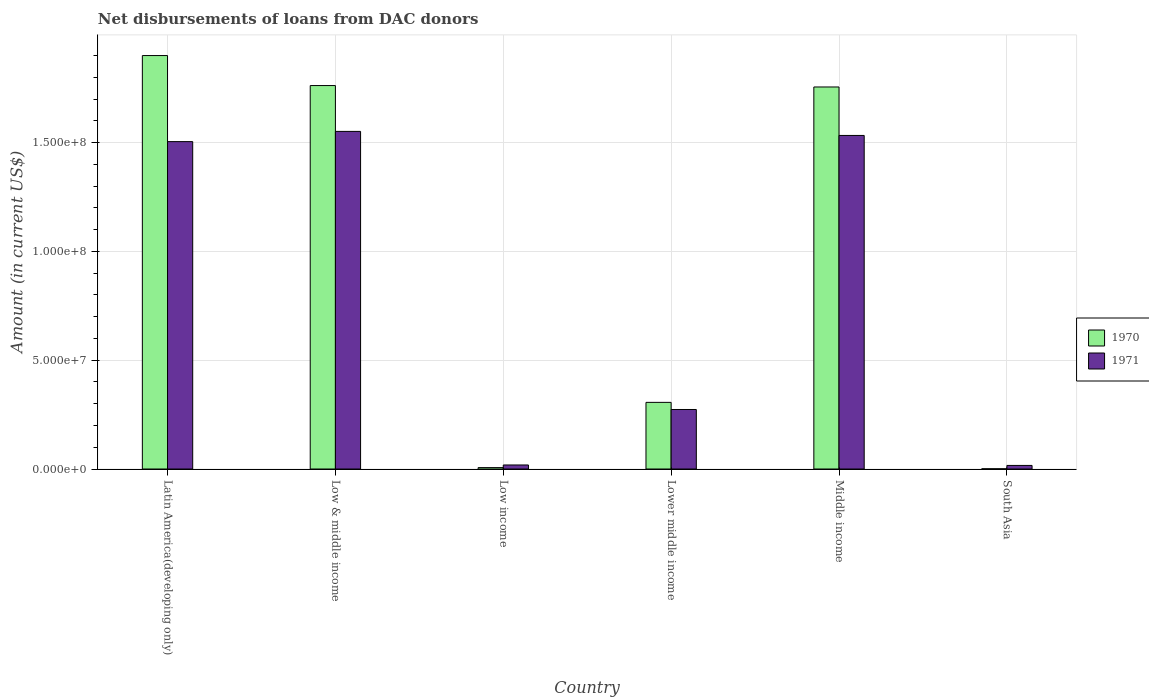How many different coloured bars are there?
Keep it short and to the point. 2. How many groups of bars are there?
Keep it short and to the point. 6. In how many cases, is the number of bars for a given country not equal to the number of legend labels?
Give a very brief answer. 0. What is the amount of loans disbursed in 1971 in Low income?
Your response must be concise. 1.86e+06. Across all countries, what is the maximum amount of loans disbursed in 1971?
Give a very brief answer. 1.55e+08. Across all countries, what is the minimum amount of loans disbursed in 1971?
Ensure brevity in your answer.  1.65e+06. In which country was the amount of loans disbursed in 1970 maximum?
Your response must be concise. Latin America(developing only). What is the total amount of loans disbursed in 1971 in the graph?
Provide a short and direct response. 4.90e+08. What is the difference between the amount of loans disbursed in 1971 in Middle income and that in South Asia?
Ensure brevity in your answer.  1.52e+08. What is the difference between the amount of loans disbursed in 1971 in Lower middle income and the amount of loans disbursed in 1970 in Low & middle income?
Make the answer very short. -1.49e+08. What is the average amount of loans disbursed in 1971 per country?
Keep it short and to the point. 8.16e+07. What is the difference between the amount of loans disbursed of/in 1971 and amount of loans disbursed of/in 1970 in Low income?
Your answer should be compact. 1.21e+06. What is the ratio of the amount of loans disbursed in 1971 in Latin America(developing only) to that in Lower middle income?
Provide a short and direct response. 5.5. Is the amount of loans disbursed in 1971 in Low & middle income less than that in Low income?
Give a very brief answer. No. What is the difference between the highest and the second highest amount of loans disbursed in 1971?
Ensure brevity in your answer.  4.69e+06. What is the difference between the highest and the lowest amount of loans disbursed in 1970?
Your response must be concise. 1.90e+08. Is the sum of the amount of loans disbursed in 1970 in Lower middle income and Middle income greater than the maximum amount of loans disbursed in 1971 across all countries?
Provide a short and direct response. Yes. How many bars are there?
Offer a very short reply. 12. Are the values on the major ticks of Y-axis written in scientific E-notation?
Your response must be concise. Yes. Where does the legend appear in the graph?
Give a very brief answer. Center right. How are the legend labels stacked?
Offer a very short reply. Vertical. What is the title of the graph?
Your answer should be very brief. Net disbursements of loans from DAC donors. Does "1991" appear as one of the legend labels in the graph?
Your answer should be compact. No. What is the label or title of the X-axis?
Keep it short and to the point. Country. What is the label or title of the Y-axis?
Make the answer very short. Amount (in current US$). What is the Amount (in current US$) of 1970 in Latin America(developing only)?
Offer a terse response. 1.90e+08. What is the Amount (in current US$) in 1971 in Latin America(developing only)?
Keep it short and to the point. 1.50e+08. What is the Amount (in current US$) of 1970 in Low & middle income?
Your response must be concise. 1.76e+08. What is the Amount (in current US$) of 1971 in Low & middle income?
Provide a short and direct response. 1.55e+08. What is the Amount (in current US$) in 1970 in Low income?
Provide a succinct answer. 6.47e+05. What is the Amount (in current US$) in 1971 in Low income?
Offer a terse response. 1.86e+06. What is the Amount (in current US$) of 1970 in Lower middle income?
Provide a succinct answer. 3.06e+07. What is the Amount (in current US$) of 1971 in Lower middle income?
Your answer should be compact. 2.74e+07. What is the Amount (in current US$) in 1970 in Middle income?
Your response must be concise. 1.76e+08. What is the Amount (in current US$) in 1971 in Middle income?
Give a very brief answer. 1.53e+08. What is the Amount (in current US$) of 1970 in South Asia?
Your response must be concise. 1.09e+05. What is the Amount (in current US$) in 1971 in South Asia?
Keep it short and to the point. 1.65e+06. Across all countries, what is the maximum Amount (in current US$) in 1970?
Your response must be concise. 1.90e+08. Across all countries, what is the maximum Amount (in current US$) of 1971?
Provide a short and direct response. 1.55e+08. Across all countries, what is the minimum Amount (in current US$) of 1970?
Provide a short and direct response. 1.09e+05. Across all countries, what is the minimum Amount (in current US$) in 1971?
Provide a short and direct response. 1.65e+06. What is the total Amount (in current US$) in 1970 in the graph?
Your response must be concise. 5.73e+08. What is the total Amount (in current US$) in 1971 in the graph?
Make the answer very short. 4.90e+08. What is the difference between the Amount (in current US$) of 1970 in Latin America(developing only) and that in Low & middle income?
Offer a terse response. 1.38e+07. What is the difference between the Amount (in current US$) of 1971 in Latin America(developing only) and that in Low & middle income?
Make the answer very short. -4.69e+06. What is the difference between the Amount (in current US$) of 1970 in Latin America(developing only) and that in Low income?
Give a very brief answer. 1.89e+08. What is the difference between the Amount (in current US$) in 1971 in Latin America(developing only) and that in Low income?
Keep it short and to the point. 1.49e+08. What is the difference between the Amount (in current US$) of 1970 in Latin America(developing only) and that in Lower middle income?
Provide a short and direct response. 1.59e+08. What is the difference between the Amount (in current US$) of 1971 in Latin America(developing only) and that in Lower middle income?
Your answer should be very brief. 1.23e+08. What is the difference between the Amount (in current US$) in 1970 in Latin America(developing only) and that in Middle income?
Offer a very short reply. 1.44e+07. What is the difference between the Amount (in current US$) of 1971 in Latin America(developing only) and that in Middle income?
Offer a very short reply. -2.84e+06. What is the difference between the Amount (in current US$) of 1970 in Latin America(developing only) and that in South Asia?
Provide a short and direct response. 1.90e+08. What is the difference between the Amount (in current US$) in 1971 in Latin America(developing only) and that in South Asia?
Your answer should be compact. 1.49e+08. What is the difference between the Amount (in current US$) in 1970 in Low & middle income and that in Low income?
Provide a succinct answer. 1.76e+08. What is the difference between the Amount (in current US$) of 1971 in Low & middle income and that in Low income?
Make the answer very short. 1.53e+08. What is the difference between the Amount (in current US$) in 1970 in Low & middle income and that in Lower middle income?
Keep it short and to the point. 1.46e+08. What is the difference between the Amount (in current US$) of 1971 in Low & middle income and that in Lower middle income?
Your answer should be compact. 1.28e+08. What is the difference between the Amount (in current US$) of 1970 in Low & middle income and that in Middle income?
Give a very brief answer. 6.47e+05. What is the difference between the Amount (in current US$) in 1971 in Low & middle income and that in Middle income?
Offer a very short reply. 1.86e+06. What is the difference between the Amount (in current US$) of 1970 in Low & middle income and that in South Asia?
Make the answer very short. 1.76e+08. What is the difference between the Amount (in current US$) in 1971 in Low & middle income and that in South Asia?
Your answer should be compact. 1.53e+08. What is the difference between the Amount (in current US$) of 1970 in Low income and that in Lower middle income?
Ensure brevity in your answer.  -3.00e+07. What is the difference between the Amount (in current US$) of 1971 in Low income and that in Lower middle income?
Provide a short and direct response. -2.55e+07. What is the difference between the Amount (in current US$) of 1970 in Low income and that in Middle income?
Your response must be concise. -1.75e+08. What is the difference between the Amount (in current US$) of 1971 in Low income and that in Middle income?
Ensure brevity in your answer.  -1.51e+08. What is the difference between the Amount (in current US$) in 1970 in Low income and that in South Asia?
Keep it short and to the point. 5.38e+05. What is the difference between the Amount (in current US$) in 1971 in Low income and that in South Asia?
Your response must be concise. 2.09e+05. What is the difference between the Amount (in current US$) of 1970 in Lower middle income and that in Middle income?
Ensure brevity in your answer.  -1.45e+08. What is the difference between the Amount (in current US$) in 1971 in Lower middle income and that in Middle income?
Your answer should be compact. -1.26e+08. What is the difference between the Amount (in current US$) of 1970 in Lower middle income and that in South Asia?
Keep it short and to the point. 3.05e+07. What is the difference between the Amount (in current US$) of 1971 in Lower middle income and that in South Asia?
Your answer should be very brief. 2.57e+07. What is the difference between the Amount (in current US$) of 1970 in Middle income and that in South Asia?
Keep it short and to the point. 1.75e+08. What is the difference between the Amount (in current US$) in 1971 in Middle income and that in South Asia?
Your answer should be compact. 1.52e+08. What is the difference between the Amount (in current US$) in 1970 in Latin America(developing only) and the Amount (in current US$) in 1971 in Low & middle income?
Your answer should be compact. 3.49e+07. What is the difference between the Amount (in current US$) in 1970 in Latin America(developing only) and the Amount (in current US$) in 1971 in Low income?
Your answer should be compact. 1.88e+08. What is the difference between the Amount (in current US$) of 1970 in Latin America(developing only) and the Amount (in current US$) of 1971 in Lower middle income?
Make the answer very short. 1.63e+08. What is the difference between the Amount (in current US$) of 1970 in Latin America(developing only) and the Amount (in current US$) of 1971 in Middle income?
Ensure brevity in your answer.  3.67e+07. What is the difference between the Amount (in current US$) of 1970 in Latin America(developing only) and the Amount (in current US$) of 1971 in South Asia?
Give a very brief answer. 1.88e+08. What is the difference between the Amount (in current US$) of 1970 in Low & middle income and the Amount (in current US$) of 1971 in Low income?
Keep it short and to the point. 1.74e+08. What is the difference between the Amount (in current US$) in 1970 in Low & middle income and the Amount (in current US$) in 1971 in Lower middle income?
Your answer should be compact. 1.49e+08. What is the difference between the Amount (in current US$) in 1970 in Low & middle income and the Amount (in current US$) in 1971 in Middle income?
Make the answer very short. 2.29e+07. What is the difference between the Amount (in current US$) in 1970 in Low & middle income and the Amount (in current US$) in 1971 in South Asia?
Ensure brevity in your answer.  1.75e+08. What is the difference between the Amount (in current US$) of 1970 in Low income and the Amount (in current US$) of 1971 in Lower middle income?
Ensure brevity in your answer.  -2.67e+07. What is the difference between the Amount (in current US$) of 1970 in Low income and the Amount (in current US$) of 1971 in Middle income?
Provide a short and direct response. -1.53e+08. What is the difference between the Amount (in current US$) of 1970 in Low income and the Amount (in current US$) of 1971 in South Asia?
Provide a succinct answer. -1.00e+06. What is the difference between the Amount (in current US$) of 1970 in Lower middle income and the Amount (in current US$) of 1971 in Middle income?
Your response must be concise. -1.23e+08. What is the difference between the Amount (in current US$) of 1970 in Lower middle income and the Amount (in current US$) of 1971 in South Asia?
Your response must be concise. 2.90e+07. What is the difference between the Amount (in current US$) of 1970 in Middle income and the Amount (in current US$) of 1971 in South Asia?
Provide a short and direct response. 1.74e+08. What is the average Amount (in current US$) in 1970 per country?
Offer a terse response. 9.55e+07. What is the average Amount (in current US$) of 1971 per country?
Keep it short and to the point. 8.16e+07. What is the difference between the Amount (in current US$) of 1970 and Amount (in current US$) of 1971 in Latin America(developing only)?
Ensure brevity in your answer.  3.96e+07. What is the difference between the Amount (in current US$) of 1970 and Amount (in current US$) of 1971 in Low & middle income?
Make the answer very short. 2.11e+07. What is the difference between the Amount (in current US$) in 1970 and Amount (in current US$) in 1971 in Low income?
Your answer should be compact. -1.21e+06. What is the difference between the Amount (in current US$) of 1970 and Amount (in current US$) of 1971 in Lower middle income?
Your answer should be very brief. 3.27e+06. What is the difference between the Amount (in current US$) of 1970 and Amount (in current US$) of 1971 in Middle income?
Offer a very short reply. 2.23e+07. What is the difference between the Amount (in current US$) of 1970 and Amount (in current US$) of 1971 in South Asia?
Provide a short and direct response. -1.54e+06. What is the ratio of the Amount (in current US$) of 1970 in Latin America(developing only) to that in Low & middle income?
Offer a terse response. 1.08. What is the ratio of the Amount (in current US$) in 1971 in Latin America(developing only) to that in Low & middle income?
Provide a short and direct response. 0.97. What is the ratio of the Amount (in current US$) in 1970 in Latin America(developing only) to that in Low income?
Your answer should be very brief. 293.65. What is the ratio of the Amount (in current US$) in 1971 in Latin America(developing only) to that in Low income?
Offer a very short reply. 80.93. What is the ratio of the Amount (in current US$) of 1970 in Latin America(developing only) to that in Lower middle income?
Your response must be concise. 6.2. What is the ratio of the Amount (in current US$) of 1971 in Latin America(developing only) to that in Lower middle income?
Your answer should be compact. 5.5. What is the ratio of the Amount (in current US$) in 1970 in Latin America(developing only) to that in Middle income?
Offer a terse response. 1.08. What is the ratio of the Amount (in current US$) of 1971 in Latin America(developing only) to that in Middle income?
Offer a terse response. 0.98. What is the ratio of the Amount (in current US$) in 1970 in Latin America(developing only) to that in South Asia?
Your response must be concise. 1743.04. What is the ratio of the Amount (in current US$) in 1971 in Latin America(developing only) to that in South Asia?
Provide a short and direct response. 91.18. What is the ratio of the Amount (in current US$) in 1970 in Low & middle income to that in Low income?
Keep it short and to the point. 272.33. What is the ratio of the Amount (in current US$) of 1971 in Low & middle income to that in Low income?
Your answer should be compact. 83.45. What is the ratio of the Amount (in current US$) of 1970 in Low & middle income to that in Lower middle income?
Make the answer very short. 5.75. What is the ratio of the Amount (in current US$) of 1971 in Low & middle income to that in Lower middle income?
Offer a very short reply. 5.67. What is the ratio of the Amount (in current US$) in 1970 in Low & middle income to that in Middle income?
Give a very brief answer. 1. What is the ratio of the Amount (in current US$) in 1971 in Low & middle income to that in Middle income?
Make the answer very short. 1.01. What is the ratio of the Amount (in current US$) of 1970 in Low & middle income to that in South Asia?
Offer a terse response. 1616.51. What is the ratio of the Amount (in current US$) in 1971 in Low & middle income to that in South Asia?
Make the answer very short. 94.02. What is the ratio of the Amount (in current US$) in 1970 in Low income to that in Lower middle income?
Your answer should be compact. 0.02. What is the ratio of the Amount (in current US$) in 1971 in Low income to that in Lower middle income?
Provide a short and direct response. 0.07. What is the ratio of the Amount (in current US$) in 1970 in Low income to that in Middle income?
Your response must be concise. 0. What is the ratio of the Amount (in current US$) in 1971 in Low income to that in Middle income?
Offer a very short reply. 0.01. What is the ratio of the Amount (in current US$) of 1970 in Low income to that in South Asia?
Make the answer very short. 5.94. What is the ratio of the Amount (in current US$) of 1971 in Low income to that in South Asia?
Your answer should be compact. 1.13. What is the ratio of the Amount (in current US$) in 1970 in Lower middle income to that in Middle income?
Ensure brevity in your answer.  0.17. What is the ratio of the Amount (in current US$) of 1971 in Lower middle income to that in Middle income?
Your answer should be very brief. 0.18. What is the ratio of the Amount (in current US$) in 1970 in Lower middle income to that in South Asia?
Your response must be concise. 280.94. What is the ratio of the Amount (in current US$) of 1971 in Lower middle income to that in South Asia?
Your response must be concise. 16.58. What is the ratio of the Amount (in current US$) in 1970 in Middle income to that in South Asia?
Provide a short and direct response. 1610.58. What is the ratio of the Amount (in current US$) of 1971 in Middle income to that in South Asia?
Ensure brevity in your answer.  92.89. What is the difference between the highest and the second highest Amount (in current US$) in 1970?
Keep it short and to the point. 1.38e+07. What is the difference between the highest and the second highest Amount (in current US$) of 1971?
Ensure brevity in your answer.  1.86e+06. What is the difference between the highest and the lowest Amount (in current US$) in 1970?
Ensure brevity in your answer.  1.90e+08. What is the difference between the highest and the lowest Amount (in current US$) of 1971?
Your answer should be very brief. 1.53e+08. 